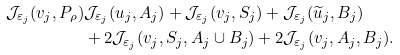<formula> <loc_0><loc_0><loc_500><loc_500>\mathcal { J } _ { \varepsilon _ { j } } ( v _ { j } , P _ { \rho } ) & \mathcal { J } _ { \varepsilon _ { j } } ( u _ { j } , A _ { j } ) + \mathcal { J } _ { \varepsilon _ { j } } ( v _ { j } , S _ { j } ) + \mathcal { J } _ { \varepsilon _ { j } } ( \widetilde { u } _ { j } , B _ { j } ) \\ & + 2 \mathcal { J } _ { \varepsilon _ { j } } ( v _ { j } , S _ { j } , A _ { j } \cup B _ { j } ) + 2 \mathcal { J } _ { \varepsilon _ { j } } ( v _ { j } , A _ { j } , B _ { j } ) .</formula> 